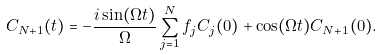<formula> <loc_0><loc_0><loc_500><loc_500>C _ { N + 1 } ( t ) = - \frac { i \sin ( \Omega t ) } { \Omega } \sum _ { j = 1 } ^ { N } f _ { j } C _ { j } ( 0 ) + \cos ( \Omega t ) C _ { N + 1 } ( 0 ) .</formula> 